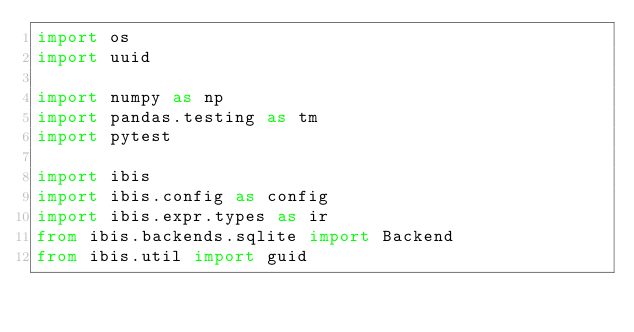<code> <loc_0><loc_0><loc_500><loc_500><_Python_>import os
import uuid

import numpy as np
import pandas.testing as tm
import pytest

import ibis
import ibis.config as config
import ibis.expr.types as ir
from ibis.backends.sqlite import Backend
from ibis.util import guid

</code> 